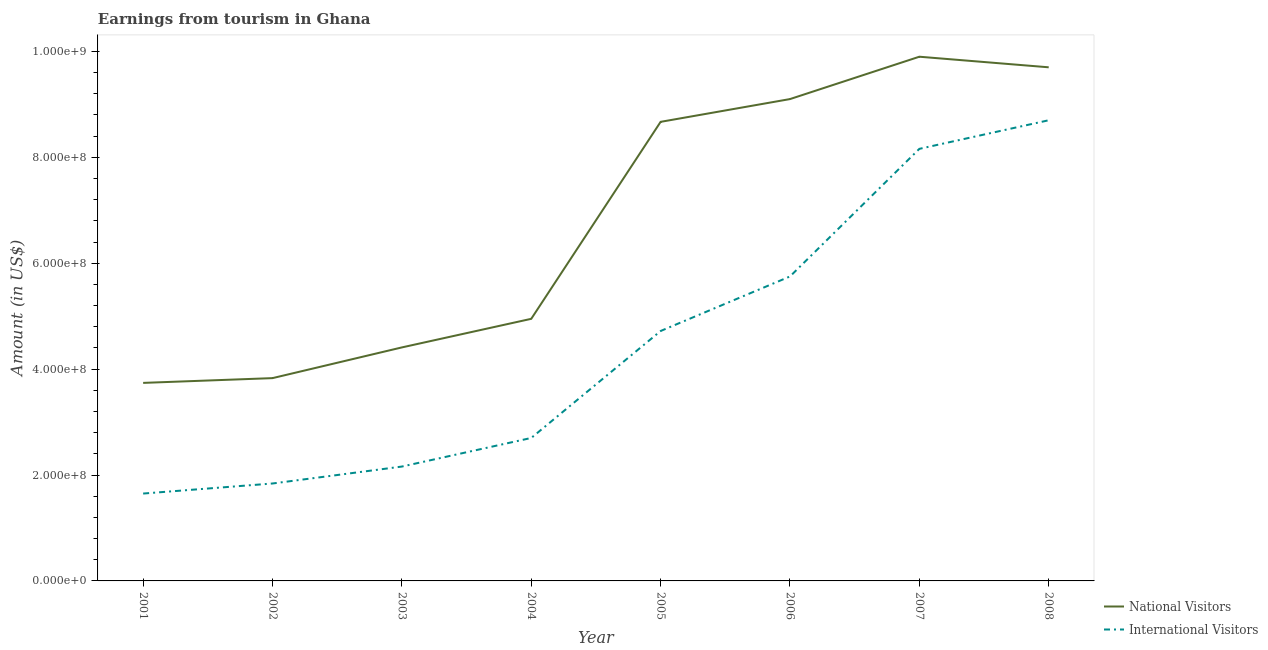How many different coloured lines are there?
Offer a very short reply. 2. Is the number of lines equal to the number of legend labels?
Provide a succinct answer. Yes. What is the amount earned from international visitors in 2007?
Provide a succinct answer. 8.16e+08. Across all years, what is the maximum amount earned from international visitors?
Offer a terse response. 8.70e+08. Across all years, what is the minimum amount earned from national visitors?
Provide a short and direct response. 3.74e+08. In which year was the amount earned from international visitors minimum?
Your response must be concise. 2001. What is the total amount earned from international visitors in the graph?
Ensure brevity in your answer.  3.57e+09. What is the difference between the amount earned from national visitors in 2001 and that in 2004?
Make the answer very short. -1.21e+08. What is the difference between the amount earned from international visitors in 2006 and the amount earned from national visitors in 2008?
Make the answer very short. -3.95e+08. What is the average amount earned from national visitors per year?
Ensure brevity in your answer.  6.79e+08. In the year 2001, what is the difference between the amount earned from international visitors and amount earned from national visitors?
Give a very brief answer. -2.09e+08. What is the ratio of the amount earned from international visitors in 2004 to that in 2008?
Provide a short and direct response. 0.31. What is the difference between the highest and the second highest amount earned from international visitors?
Offer a terse response. 5.40e+07. What is the difference between the highest and the lowest amount earned from international visitors?
Your answer should be compact. 7.05e+08. Is the sum of the amount earned from national visitors in 2002 and 2007 greater than the maximum amount earned from international visitors across all years?
Your answer should be very brief. Yes. Does the amount earned from international visitors monotonically increase over the years?
Offer a terse response. Yes. How many lines are there?
Your answer should be compact. 2. What is the difference between two consecutive major ticks on the Y-axis?
Offer a terse response. 2.00e+08. Are the values on the major ticks of Y-axis written in scientific E-notation?
Ensure brevity in your answer.  Yes. Does the graph contain any zero values?
Make the answer very short. No. Does the graph contain grids?
Make the answer very short. No. What is the title of the graph?
Your answer should be compact. Earnings from tourism in Ghana. Does "Net savings(excluding particulate emission damage)" appear as one of the legend labels in the graph?
Make the answer very short. No. What is the label or title of the X-axis?
Your response must be concise. Year. What is the label or title of the Y-axis?
Your answer should be compact. Amount (in US$). What is the Amount (in US$) of National Visitors in 2001?
Offer a terse response. 3.74e+08. What is the Amount (in US$) of International Visitors in 2001?
Offer a very short reply. 1.65e+08. What is the Amount (in US$) in National Visitors in 2002?
Your answer should be very brief. 3.83e+08. What is the Amount (in US$) of International Visitors in 2002?
Offer a very short reply. 1.84e+08. What is the Amount (in US$) in National Visitors in 2003?
Your response must be concise. 4.41e+08. What is the Amount (in US$) of International Visitors in 2003?
Your response must be concise. 2.16e+08. What is the Amount (in US$) of National Visitors in 2004?
Offer a terse response. 4.95e+08. What is the Amount (in US$) in International Visitors in 2004?
Ensure brevity in your answer.  2.70e+08. What is the Amount (in US$) in National Visitors in 2005?
Your answer should be very brief. 8.67e+08. What is the Amount (in US$) in International Visitors in 2005?
Offer a very short reply. 4.72e+08. What is the Amount (in US$) in National Visitors in 2006?
Your response must be concise. 9.10e+08. What is the Amount (in US$) of International Visitors in 2006?
Keep it short and to the point. 5.75e+08. What is the Amount (in US$) in National Visitors in 2007?
Your response must be concise. 9.90e+08. What is the Amount (in US$) in International Visitors in 2007?
Ensure brevity in your answer.  8.16e+08. What is the Amount (in US$) in National Visitors in 2008?
Make the answer very short. 9.70e+08. What is the Amount (in US$) of International Visitors in 2008?
Your response must be concise. 8.70e+08. Across all years, what is the maximum Amount (in US$) in National Visitors?
Your answer should be compact. 9.90e+08. Across all years, what is the maximum Amount (in US$) of International Visitors?
Make the answer very short. 8.70e+08. Across all years, what is the minimum Amount (in US$) of National Visitors?
Provide a succinct answer. 3.74e+08. Across all years, what is the minimum Amount (in US$) in International Visitors?
Offer a terse response. 1.65e+08. What is the total Amount (in US$) in National Visitors in the graph?
Keep it short and to the point. 5.43e+09. What is the total Amount (in US$) of International Visitors in the graph?
Your response must be concise. 3.57e+09. What is the difference between the Amount (in US$) of National Visitors in 2001 and that in 2002?
Keep it short and to the point. -9.00e+06. What is the difference between the Amount (in US$) of International Visitors in 2001 and that in 2002?
Provide a short and direct response. -1.90e+07. What is the difference between the Amount (in US$) of National Visitors in 2001 and that in 2003?
Your answer should be compact. -6.70e+07. What is the difference between the Amount (in US$) in International Visitors in 2001 and that in 2003?
Your answer should be very brief. -5.10e+07. What is the difference between the Amount (in US$) in National Visitors in 2001 and that in 2004?
Your answer should be very brief. -1.21e+08. What is the difference between the Amount (in US$) of International Visitors in 2001 and that in 2004?
Your answer should be very brief. -1.05e+08. What is the difference between the Amount (in US$) of National Visitors in 2001 and that in 2005?
Your answer should be very brief. -4.93e+08. What is the difference between the Amount (in US$) of International Visitors in 2001 and that in 2005?
Offer a very short reply. -3.07e+08. What is the difference between the Amount (in US$) of National Visitors in 2001 and that in 2006?
Your response must be concise. -5.36e+08. What is the difference between the Amount (in US$) in International Visitors in 2001 and that in 2006?
Make the answer very short. -4.10e+08. What is the difference between the Amount (in US$) of National Visitors in 2001 and that in 2007?
Keep it short and to the point. -6.16e+08. What is the difference between the Amount (in US$) of International Visitors in 2001 and that in 2007?
Provide a short and direct response. -6.51e+08. What is the difference between the Amount (in US$) of National Visitors in 2001 and that in 2008?
Your answer should be very brief. -5.96e+08. What is the difference between the Amount (in US$) in International Visitors in 2001 and that in 2008?
Your response must be concise. -7.05e+08. What is the difference between the Amount (in US$) in National Visitors in 2002 and that in 2003?
Offer a terse response. -5.80e+07. What is the difference between the Amount (in US$) of International Visitors in 2002 and that in 2003?
Offer a terse response. -3.20e+07. What is the difference between the Amount (in US$) of National Visitors in 2002 and that in 2004?
Make the answer very short. -1.12e+08. What is the difference between the Amount (in US$) of International Visitors in 2002 and that in 2004?
Make the answer very short. -8.60e+07. What is the difference between the Amount (in US$) in National Visitors in 2002 and that in 2005?
Give a very brief answer. -4.84e+08. What is the difference between the Amount (in US$) in International Visitors in 2002 and that in 2005?
Offer a very short reply. -2.88e+08. What is the difference between the Amount (in US$) of National Visitors in 2002 and that in 2006?
Offer a terse response. -5.27e+08. What is the difference between the Amount (in US$) of International Visitors in 2002 and that in 2006?
Your response must be concise. -3.91e+08. What is the difference between the Amount (in US$) in National Visitors in 2002 and that in 2007?
Keep it short and to the point. -6.07e+08. What is the difference between the Amount (in US$) in International Visitors in 2002 and that in 2007?
Make the answer very short. -6.32e+08. What is the difference between the Amount (in US$) in National Visitors in 2002 and that in 2008?
Give a very brief answer. -5.87e+08. What is the difference between the Amount (in US$) of International Visitors in 2002 and that in 2008?
Offer a terse response. -6.86e+08. What is the difference between the Amount (in US$) in National Visitors in 2003 and that in 2004?
Make the answer very short. -5.40e+07. What is the difference between the Amount (in US$) in International Visitors in 2003 and that in 2004?
Keep it short and to the point. -5.40e+07. What is the difference between the Amount (in US$) in National Visitors in 2003 and that in 2005?
Provide a short and direct response. -4.26e+08. What is the difference between the Amount (in US$) of International Visitors in 2003 and that in 2005?
Your answer should be very brief. -2.56e+08. What is the difference between the Amount (in US$) of National Visitors in 2003 and that in 2006?
Provide a succinct answer. -4.69e+08. What is the difference between the Amount (in US$) in International Visitors in 2003 and that in 2006?
Give a very brief answer. -3.59e+08. What is the difference between the Amount (in US$) in National Visitors in 2003 and that in 2007?
Provide a short and direct response. -5.49e+08. What is the difference between the Amount (in US$) of International Visitors in 2003 and that in 2007?
Give a very brief answer. -6.00e+08. What is the difference between the Amount (in US$) of National Visitors in 2003 and that in 2008?
Your answer should be very brief. -5.29e+08. What is the difference between the Amount (in US$) in International Visitors in 2003 and that in 2008?
Provide a short and direct response. -6.54e+08. What is the difference between the Amount (in US$) in National Visitors in 2004 and that in 2005?
Your answer should be compact. -3.72e+08. What is the difference between the Amount (in US$) of International Visitors in 2004 and that in 2005?
Make the answer very short. -2.02e+08. What is the difference between the Amount (in US$) of National Visitors in 2004 and that in 2006?
Your answer should be compact. -4.15e+08. What is the difference between the Amount (in US$) of International Visitors in 2004 and that in 2006?
Your answer should be compact. -3.05e+08. What is the difference between the Amount (in US$) in National Visitors in 2004 and that in 2007?
Your answer should be compact. -4.95e+08. What is the difference between the Amount (in US$) in International Visitors in 2004 and that in 2007?
Keep it short and to the point. -5.46e+08. What is the difference between the Amount (in US$) in National Visitors in 2004 and that in 2008?
Provide a succinct answer. -4.75e+08. What is the difference between the Amount (in US$) in International Visitors in 2004 and that in 2008?
Provide a short and direct response. -6.00e+08. What is the difference between the Amount (in US$) of National Visitors in 2005 and that in 2006?
Your response must be concise. -4.30e+07. What is the difference between the Amount (in US$) of International Visitors in 2005 and that in 2006?
Give a very brief answer. -1.03e+08. What is the difference between the Amount (in US$) of National Visitors in 2005 and that in 2007?
Offer a terse response. -1.23e+08. What is the difference between the Amount (in US$) in International Visitors in 2005 and that in 2007?
Your answer should be very brief. -3.44e+08. What is the difference between the Amount (in US$) of National Visitors in 2005 and that in 2008?
Give a very brief answer. -1.03e+08. What is the difference between the Amount (in US$) of International Visitors in 2005 and that in 2008?
Ensure brevity in your answer.  -3.98e+08. What is the difference between the Amount (in US$) of National Visitors in 2006 and that in 2007?
Make the answer very short. -8.00e+07. What is the difference between the Amount (in US$) in International Visitors in 2006 and that in 2007?
Offer a very short reply. -2.41e+08. What is the difference between the Amount (in US$) in National Visitors in 2006 and that in 2008?
Offer a very short reply. -6.00e+07. What is the difference between the Amount (in US$) of International Visitors in 2006 and that in 2008?
Provide a succinct answer. -2.95e+08. What is the difference between the Amount (in US$) in International Visitors in 2007 and that in 2008?
Your answer should be compact. -5.40e+07. What is the difference between the Amount (in US$) of National Visitors in 2001 and the Amount (in US$) of International Visitors in 2002?
Your answer should be very brief. 1.90e+08. What is the difference between the Amount (in US$) in National Visitors in 2001 and the Amount (in US$) in International Visitors in 2003?
Offer a very short reply. 1.58e+08. What is the difference between the Amount (in US$) in National Visitors in 2001 and the Amount (in US$) in International Visitors in 2004?
Give a very brief answer. 1.04e+08. What is the difference between the Amount (in US$) in National Visitors in 2001 and the Amount (in US$) in International Visitors in 2005?
Offer a terse response. -9.80e+07. What is the difference between the Amount (in US$) of National Visitors in 2001 and the Amount (in US$) of International Visitors in 2006?
Offer a terse response. -2.01e+08. What is the difference between the Amount (in US$) in National Visitors in 2001 and the Amount (in US$) in International Visitors in 2007?
Provide a succinct answer. -4.42e+08. What is the difference between the Amount (in US$) of National Visitors in 2001 and the Amount (in US$) of International Visitors in 2008?
Ensure brevity in your answer.  -4.96e+08. What is the difference between the Amount (in US$) of National Visitors in 2002 and the Amount (in US$) of International Visitors in 2003?
Keep it short and to the point. 1.67e+08. What is the difference between the Amount (in US$) of National Visitors in 2002 and the Amount (in US$) of International Visitors in 2004?
Keep it short and to the point. 1.13e+08. What is the difference between the Amount (in US$) in National Visitors in 2002 and the Amount (in US$) in International Visitors in 2005?
Make the answer very short. -8.90e+07. What is the difference between the Amount (in US$) of National Visitors in 2002 and the Amount (in US$) of International Visitors in 2006?
Your response must be concise. -1.92e+08. What is the difference between the Amount (in US$) in National Visitors in 2002 and the Amount (in US$) in International Visitors in 2007?
Keep it short and to the point. -4.33e+08. What is the difference between the Amount (in US$) of National Visitors in 2002 and the Amount (in US$) of International Visitors in 2008?
Give a very brief answer. -4.87e+08. What is the difference between the Amount (in US$) in National Visitors in 2003 and the Amount (in US$) in International Visitors in 2004?
Provide a short and direct response. 1.71e+08. What is the difference between the Amount (in US$) in National Visitors in 2003 and the Amount (in US$) in International Visitors in 2005?
Provide a succinct answer. -3.10e+07. What is the difference between the Amount (in US$) in National Visitors in 2003 and the Amount (in US$) in International Visitors in 2006?
Make the answer very short. -1.34e+08. What is the difference between the Amount (in US$) in National Visitors in 2003 and the Amount (in US$) in International Visitors in 2007?
Give a very brief answer. -3.75e+08. What is the difference between the Amount (in US$) of National Visitors in 2003 and the Amount (in US$) of International Visitors in 2008?
Offer a very short reply. -4.29e+08. What is the difference between the Amount (in US$) in National Visitors in 2004 and the Amount (in US$) in International Visitors in 2005?
Provide a succinct answer. 2.30e+07. What is the difference between the Amount (in US$) in National Visitors in 2004 and the Amount (in US$) in International Visitors in 2006?
Make the answer very short. -8.00e+07. What is the difference between the Amount (in US$) in National Visitors in 2004 and the Amount (in US$) in International Visitors in 2007?
Provide a short and direct response. -3.21e+08. What is the difference between the Amount (in US$) in National Visitors in 2004 and the Amount (in US$) in International Visitors in 2008?
Offer a very short reply. -3.75e+08. What is the difference between the Amount (in US$) of National Visitors in 2005 and the Amount (in US$) of International Visitors in 2006?
Your answer should be very brief. 2.92e+08. What is the difference between the Amount (in US$) in National Visitors in 2005 and the Amount (in US$) in International Visitors in 2007?
Ensure brevity in your answer.  5.10e+07. What is the difference between the Amount (in US$) of National Visitors in 2005 and the Amount (in US$) of International Visitors in 2008?
Keep it short and to the point. -3.00e+06. What is the difference between the Amount (in US$) in National Visitors in 2006 and the Amount (in US$) in International Visitors in 2007?
Give a very brief answer. 9.40e+07. What is the difference between the Amount (in US$) of National Visitors in 2006 and the Amount (in US$) of International Visitors in 2008?
Provide a succinct answer. 4.00e+07. What is the difference between the Amount (in US$) of National Visitors in 2007 and the Amount (in US$) of International Visitors in 2008?
Make the answer very short. 1.20e+08. What is the average Amount (in US$) of National Visitors per year?
Provide a succinct answer. 6.79e+08. What is the average Amount (in US$) of International Visitors per year?
Your answer should be compact. 4.46e+08. In the year 2001, what is the difference between the Amount (in US$) of National Visitors and Amount (in US$) of International Visitors?
Your response must be concise. 2.09e+08. In the year 2002, what is the difference between the Amount (in US$) in National Visitors and Amount (in US$) in International Visitors?
Your answer should be very brief. 1.99e+08. In the year 2003, what is the difference between the Amount (in US$) in National Visitors and Amount (in US$) in International Visitors?
Your response must be concise. 2.25e+08. In the year 2004, what is the difference between the Amount (in US$) of National Visitors and Amount (in US$) of International Visitors?
Your response must be concise. 2.25e+08. In the year 2005, what is the difference between the Amount (in US$) of National Visitors and Amount (in US$) of International Visitors?
Ensure brevity in your answer.  3.95e+08. In the year 2006, what is the difference between the Amount (in US$) in National Visitors and Amount (in US$) in International Visitors?
Offer a terse response. 3.35e+08. In the year 2007, what is the difference between the Amount (in US$) of National Visitors and Amount (in US$) of International Visitors?
Your answer should be very brief. 1.74e+08. In the year 2008, what is the difference between the Amount (in US$) of National Visitors and Amount (in US$) of International Visitors?
Provide a succinct answer. 1.00e+08. What is the ratio of the Amount (in US$) in National Visitors in 2001 to that in 2002?
Ensure brevity in your answer.  0.98. What is the ratio of the Amount (in US$) in International Visitors in 2001 to that in 2002?
Provide a short and direct response. 0.9. What is the ratio of the Amount (in US$) in National Visitors in 2001 to that in 2003?
Provide a short and direct response. 0.85. What is the ratio of the Amount (in US$) in International Visitors in 2001 to that in 2003?
Ensure brevity in your answer.  0.76. What is the ratio of the Amount (in US$) in National Visitors in 2001 to that in 2004?
Provide a succinct answer. 0.76. What is the ratio of the Amount (in US$) of International Visitors in 2001 to that in 2004?
Ensure brevity in your answer.  0.61. What is the ratio of the Amount (in US$) of National Visitors in 2001 to that in 2005?
Offer a very short reply. 0.43. What is the ratio of the Amount (in US$) in International Visitors in 2001 to that in 2005?
Provide a short and direct response. 0.35. What is the ratio of the Amount (in US$) of National Visitors in 2001 to that in 2006?
Provide a succinct answer. 0.41. What is the ratio of the Amount (in US$) of International Visitors in 2001 to that in 2006?
Your response must be concise. 0.29. What is the ratio of the Amount (in US$) of National Visitors in 2001 to that in 2007?
Make the answer very short. 0.38. What is the ratio of the Amount (in US$) of International Visitors in 2001 to that in 2007?
Give a very brief answer. 0.2. What is the ratio of the Amount (in US$) of National Visitors in 2001 to that in 2008?
Ensure brevity in your answer.  0.39. What is the ratio of the Amount (in US$) of International Visitors in 2001 to that in 2008?
Your answer should be very brief. 0.19. What is the ratio of the Amount (in US$) in National Visitors in 2002 to that in 2003?
Offer a very short reply. 0.87. What is the ratio of the Amount (in US$) of International Visitors in 2002 to that in 2003?
Give a very brief answer. 0.85. What is the ratio of the Amount (in US$) of National Visitors in 2002 to that in 2004?
Your response must be concise. 0.77. What is the ratio of the Amount (in US$) in International Visitors in 2002 to that in 2004?
Provide a succinct answer. 0.68. What is the ratio of the Amount (in US$) in National Visitors in 2002 to that in 2005?
Your response must be concise. 0.44. What is the ratio of the Amount (in US$) in International Visitors in 2002 to that in 2005?
Your answer should be very brief. 0.39. What is the ratio of the Amount (in US$) in National Visitors in 2002 to that in 2006?
Offer a very short reply. 0.42. What is the ratio of the Amount (in US$) of International Visitors in 2002 to that in 2006?
Provide a succinct answer. 0.32. What is the ratio of the Amount (in US$) in National Visitors in 2002 to that in 2007?
Offer a terse response. 0.39. What is the ratio of the Amount (in US$) of International Visitors in 2002 to that in 2007?
Your answer should be very brief. 0.23. What is the ratio of the Amount (in US$) of National Visitors in 2002 to that in 2008?
Keep it short and to the point. 0.39. What is the ratio of the Amount (in US$) of International Visitors in 2002 to that in 2008?
Offer a terse response. 0.21. What is the ratio of the Amount (in US$) of National Visitors in 2003 to that in 2004?
Ensure brevity in your answer.  0.89. What is the ratio of the Amount (in US$) of International Visitors in 2003 to that in 2004?
Your answer should be compact. 0.8. What is the ratio of the Amount (in US$) in National Visitors in 2003 to that in 2005?
Offer a terse response. 0.51. What is the ratio of the Amount (in US$) of International Visitors in 2003 to that in 2005?
Offer a very short reply. 0.46. What is the ratio of the Amount (in US$) of National Visitors in 2003 to that in 2006?
Your answer should be compact. 0.48. What is the ratio of the Amount (in US$) in International Visitors in 2003 to that in 2006?
Your response must be concise. 0.38. What is the ratio of the Amount (in US$) in National Visitors in 2003 to that in 2007?
Keep it short and to the point. 0.45. What is the ratio of the Amount (in US$) of International Visitors in 2003 to that in 2007?
Make the answer very short. 0.26. What is the ratio of the Amount (in US$) of National Visitors in 2003 to that in 2008?
Your response must be concise. 0.45. What is the ratio of the Amount (in US$) in International Visitors in 2003 to that in 2008?
Your answer should be very brief. 0.25. What is the ratio of the Amount (in US$) in National Visitors in 2004 to that in 2005?
Provide a succinct answer. 0.57. What is the ratio of the Amount (in US$) in International Visitors in 2004 to that in 2005?
Provide a succinct answer. 0.57. What is the ratio of the Amount (in US$) in National Visitors in 2004 to that in 2006?
Give a very brief answer. 0.54. What is the ratio of the Amount (in US$) in International Visitors in 2004 to that in 2006?
Make the answer very short. 0.47. What is the ratio of the Amount (in US$) of National Visitors in 2004 to that in 2007?
Provide a short and direct response. 0.5. What is the ratio of the Amount (in US$) of International Visitors in 2004 to that in 2007?
Ensure brevity in your answer.  0.33. What is the ratio of the Amount (in US$) in National Visitors in 2004 to that in 2008?
Provide a short and direct response. 0.51. What is the ratio of the Amount (in US$) of International Visitors in 2004 to that in 2008?
Keep it short and to the point. 0.31. What is the ratio of the Amount (in US$) of National Visitors in 2005 to that in 2006?
Make the answer very short. 0.95. What is the ratio of the Amount (in US$) of International Visitors in 2005 to that in 2006?
Your response must be concise. 0.82. What is the ratio of the Amount (in US$) of National Visitors in 2005 to that in 2007?
Offer a terse response. 0.88. What is the ratio of the Amount (in US$) in International Visitors in 2005 to that in 2007?
Give a very brief answer. 0.58. What is the ratio of the Amount (in US$) of National Visitors in 2005 to that in 2008?
Ensure brevity in your answer.  0.89. What is the ratio of the Amount (in US$) of International Visitors in 2005 to that in 2008?
Make the answer very short. 0.54. What is the ratio of the Amount (in US$) of National Visitors in 2006 to that in 2007?
Your response must be concise. 0.92. What is the ratio of the Amount (in US$) of International Visitors in 2006 to that in 2007?
Your response must be concise. 0.7. What is the ratio of the Amount (in US$) of National Visitors in 2006 to that in 2008?
Give a very brief answer. 0.94. What is the ratio of the Amount (in US$) of International Visitors in 2006 to that in 2008?
Ensure brevity in your answer.  0.66. What is the ratio of the Amount (in US$) in National Visitors in 2007 to that in 2008?
Provide a succinct answer. 1.02. What is the ratio of the Amount (in US$) in International Visitors in 2007 to that in 2008?
Offer a very short reply. 0.94. What is the difference between the highest and the second highest Amount (in US$) in International Visitors?
Offer a very short reply. 5.40e+07. What is the difference between the highest and the lowest Amount (in US$) in National Visitors?
Your response must be concise. 6.16e+08. What is the difference between the highest and the lowest Amount (in US$) in International Visitors?
Make the answer very short. 7.05e+08. 